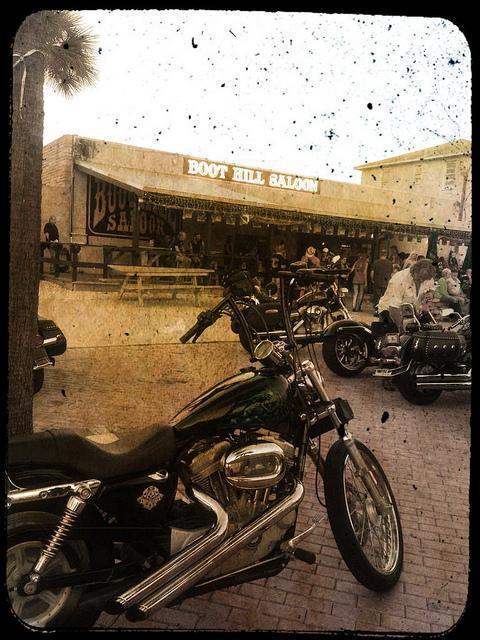How many motorcycles can you see?
Give a very brief answer. 3. How many people are there?
Give a very brief answer. 2. 